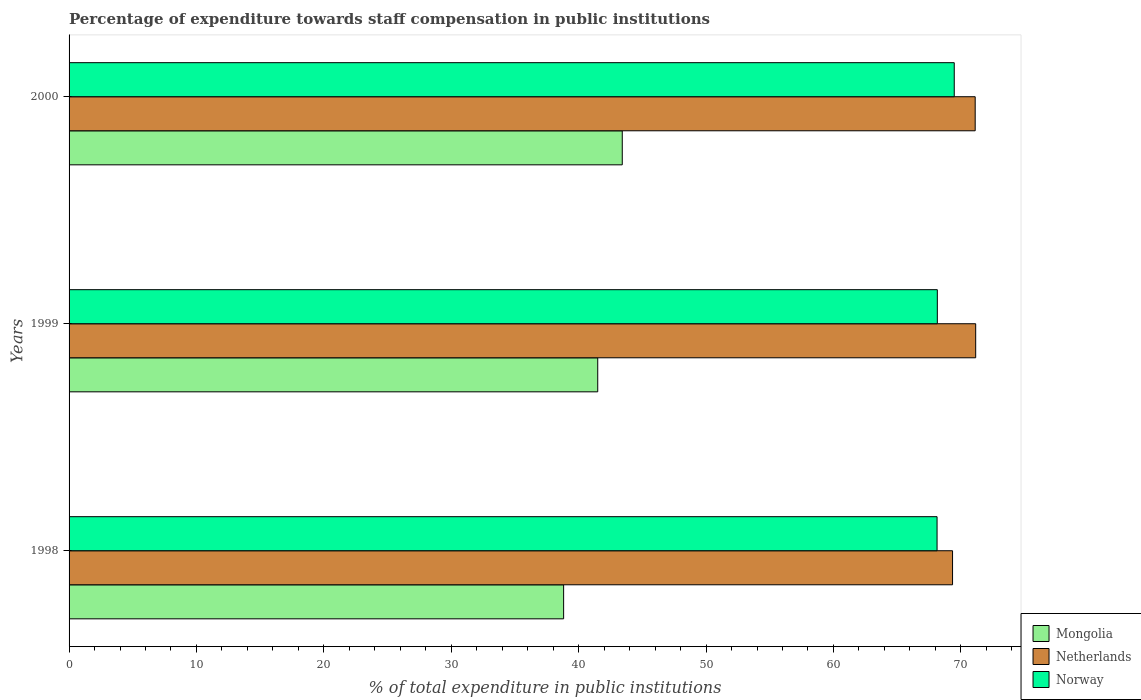How many different coloured bars are there?
Your answer should be compact. 3. How many groups of bars are there?
Ensure brevity in your answer.  3. How many bars are there on the 2nd tick from the top?
Your answer should be compact. 3. How many bars are there on the 2nd tick from the bottom?
Your answer should be compact. 3. In how many cases, is the number of bars for a given year not equal to the number of legend labels?
Make the answer very short. 0. What is the percentage of expenditure towards staff compensation in Mongolia in 1999?
Provide a succinct answer. 41.5. Across all years, what is the maximum percentage of expenditure towards staff compensation in Mongolia?
Your answer should be compact. 43.42. Across all years, what is the minimum percentage of expenditure towards staff compensation in Mongolia?
Your answer should be compact. 38.82. In which year was the percentage of expenditure towards staff compensation in Mongolia maximum?
Offer a very short reply. 2000. What is the total percentage of expenditure towards staff compensation in Netherlands in the graph?
Your response must be concise. 211.65. What is the difference between the percentage of expenditure towards staff compensation in Netherlands in 1999 and that in 2000?
Your response must be concise. 0.04. What is the difference between the percentage of expenditure towards staff compensation in Mongolia in 1998 and the percentage of expenditure towards staff compensation in Norway in 1999?
Give a very brief answer. -29.34. What is the average percentage of expenditure towards staff compensation in Norway per year?
Offer a very short reply. 68.59. In the year 1999, what is the difference between the percentage of expenditure towards staff compensation in Norway and percentage of expenditure towards staff compensation in Mongolia?
Make the answer very short. 26.66. What is the ratio of the percentage of expenditure towards staff compensation in Netherlands in 1998 to that in 1999?
Offer a terse response. 0.97. Is the percentage of expenditure towards staff compensation in Mongolia in 1999 less than that in 2000?
Provide a short and direct response. Yes. What is the difference between the highest and the second highest percentage of expenditure towards staff compensation in Norway?
Ensure brevity in your answer.  1.33. What is the difference between the highest and the lowest percentage of expenditure towards staff compensation in Norway?
Your response must be concise. 1.35. In how many years, is the percentage of expenditure towards staff compensation in Norway greater than the average percentage of expenditure towards staff compensation in Norway taken over all years?
Ensure brevity in your answer.  1. What does the 1st bar from the top in 1999 represents?
Your response must be concise. Norway. What does the 3rd bar from the bottom in 1998 represents?
Offer a terse response. Norway. How many bars are there?
Give a very brief answer. 9. Are all the bars in the graph horizontal?
Provide a short and direct response. Yes. Does the graph contain grids?
Ensure brevity in your answer.  No. How many legend labels are there?
Provide a succinct answer. 3. What is the title of the graph?
Make the answer very short. Percentage of expenditure towards staff compensation in public institutions. Does "Seychelles" appear as one of the legend labels in the graph?
Keep it short and to the point. No. What is the label or title of the X-axis?
Make the answer very short. % of total expenditure in public institutions. What is the % of total expenditure in public institutions of Mongolia in 1998?
Provide a short and direct response. 38.82. What is the % of total expenditure in public institutions in Netherlands in 1998?
Keep it short and to the point. 69.35. What is the % of total expenditure in public institutions of Norway in 1998?
Provide a short and direct response. 68.14. What is the % of total expenditure in public institutions of Mongolia in 1999?
Your response must be concise. 41.5. What is the % of total expenditure in public institutions in Netherlands in 1999?
Offer a terse response. 71.17. What is the % of total expenditure in public institutions in Norway in 1999?
Keep it short and to the point. 68.16. What is the % of total expenditure in public institutions of Mongolia in 2000?
Ensure brevity in your answer.  43.42. What is the % of total expenditure in public institutions in Netherlands in 2000?
Give a very brief answer. 71.13. What is the % of total expenditure in public institutions in Norway in 2000?
Ensure brevity in your answer.  69.48. Across all years, what is the maximum % of total expenditure in public institutions of Mongolia?
Offer a very short reply. 43.42. Across all years, what is the maximum % of total expenditure in public institutions of Netherlands?
Your response must be concise. 71.17. Across all years, what is the maximum % of total expenditure in public institutions of Norway?
Offer a terse response. 69.48. Across all years, what is the minimum % of total expenditure in public institutions in Mongolia?
Offer a terse response. 38.82. Across all years, what is the minimum % of total expenditure in public institutions in Netherlands?
Your answer should be compact. 69.35. Across all years, what is the minimum % of total expenditure in public institutions in Norway?
Your answer should be very brief. 68.14. What is the total % of total expenditure in public institutions of Mongolia in the graph?
Give a very brief answer. 123.74. What is the total % of total expenditure in public institutions of Netherlands in the graph?
Give a very brief answer. 211.65. What is the total % of total expenditure in public institutions in Norway in the graph?
Ensure brevity in your answer.  205.78. What is the difference between the % of total expenditure in public institutions in Mongolia in 1998 and that in 1999?
Keep it short and to the point. -2.68. What is the difference between the % of total expenditure in public institutions in Netherlands in 1998 and that in 1999?
Ensure brevity in your answer.  -1.82. What is the difference between the % of total expenditure in public institutions in Norway in 1998 and that in 1999?
Provide a short and direct response. -0.02. What is the difference between the % of total expenditure in public institutions of Mongolia in 1998 and that in 2000?
Your answer should be very brief. -4.6. What is the difference between the % of total expenditure in public institutions of Netherlands in 1998 and that in 2000?
Provide a short and direct response. -1.78. What is the difference between the % of total expenditure in public institutions in Norway in 1998 and that in 2000?
Keep it short and to the point. -1.35. What is the difference between the % of total expenditure in public institutions of Mongolia in 1999 and that in 2000?
Your answer should be compact. -1.93. What is the difference between the % of total expenditure in public institutions of Netherlands in 1999 and that in 2000?
Offer a very short reply. 0.04. What is the difference between the % of total expenditure in public institutions of Norway in 1999 and that in 2000?
Keep it short and to the point. -1.33. What is the difference between the % of total expenditure in public institutions in Mongolia in 1998 and the % of total expenditure in public institutions in Netherlands in 1999?
Offer a very short reply. -32.35. What is the difference between the % of total expenditure in public institutions in Mongolia in 1998 and the % of total expenditure in public institutions in Norway in 1999?
Make the answer very short. -29.34. What is the difference between the % of total expenditure in public institutions in Netherlands in 1998 and the % of total expenditure in public institutions in Norway in 1999?
Your answer should be compact. 1.19. What is the difference between the % of total expenditure in public institutions of Mongolia in 1998 and the % of total expenditure in public institutions of Netherlands in 2000?
Offer a terse response. -32.31. What is the difference between the % of total expenditure in public institutions in Mongolia in 1998 and the % of total expenditure in public institutions in Norway in 2000?
Offer a terse response. -30.66. What is the difference between the % of total expenditure in public institutions in Netherlands in 1998 and the % of total expenditure in public institutions in Norway in 2000?
Give a very brief answer. -0.13. What is the difference between the % of total expenditure in public institutions of Mongolia in 1999 and the % of total expenditure in public institutions of Netherlands in 2000?
Offer a very short reply. -29.63. What is the difference between the % of total expenditure in public institutions of Mongolia in 1999 and the % of total expenditure in public institutions of Norway in 2000?
Ensure brevity in your answer.  -27.98. What is the difference between the % of total expenditure in public institutions in Netherlands in 1999 and the % of total expenditure in public institutions in Norway in 2000?
Keep it short and to the point. 1.68. What is the average % of total expenditure in public institutions of Mongolia per year?
Your answer should be very brief. 41.25. What is the average % of total expenditure in public institutions in Netherlands per year?
Your answer should be very brief. 70.55. What is the average % of total expenditure in public institutions of Norway per year?
Provide a short and direct response. 68.59. In the year 1998, what is the difference between the % of total expenditure in public institutions of Mongolia and % of total expenditure in public institutions of Netherlands?
Your answer should be compact. -30.53. In the year 1998, what is the difference between the % of total expenditure in public institutions in Mongolia and % of total expenditure in public institutions in Norway?
Give a very brief answer. -29.31. In the year 1998, what is the difference between the % of total expenditure in public institutions in Netherlands and % of total expenditure in public institutions in Norway?
Your answer should be compact. 1.22. In the year 1999, what is the difference between the % of total expenditure in public institutions in Mongolia and % of total expenditure in public institutions in Netherlands?
Your answer should be very brief. -29.67. In the year 1999, what is the difference between the % of total expenditure in public institutions in Mongolia and % of total expenditure in public institutions in Norway?
Your response must be concise. -26.66. In the year 1999, what is the difference between the % of total expenditure in public institutions in Netherlands and % of total expenditure in public institutions in Norway?
Keep it short and to the point. 3.01. In the year 2000, what is the difference between the % of total expenditure in public institutions of Mongolia and % of total expenditure in public institutions of Netherlands?
Your response must be concise. -27.7. In the year 2000, what is the difference between the % of total expenditure in public institutions of Mongolia and % of total expenditure in public institutions of Norway?
Your answer should be very brief. -26.06. In the year 2000, what is the difference between the % of total expenditure in public institutions in Netherlands and % of total expenditure in public institutions in Norway?
Provide a succinct answer. 1.64. What is the ratio of the % of total expenditure in public institutions of Mongolia in 1998 to that in 1999?
Your response must be concise. 0.94. What is the ratio of the % of total expenditure in public institutions of Netherlands in 1998 to that in 1999?
Offer a very short reply. 0.97. What is the ratio of the % of total expenditure in public institutions of Norway in 1998 to that in 1999?
Your answer should be compact. 1. What is the ratio of the % of total expenditure in public institutions of Mongolia in 1998 to that in 2000?
Your response must be concise. 0.89. What is the ratio of the % of total expenditure in public institutions in Netherlands in 1998 to that in 2000?
Offer a very short reply. 0.97. What is the ratio of the % of total expenditure in public institutions of Norway in 1998 to that in 2000?
Ensure brevity in your answer.  0.98. What is the ratio of the % of total expenditure in public institutions in Mongolia in 1999 to that in 2000?
Make the answer very short. 0.96. What is the ratio of the % of total expenditure in public institutions of Netherlands in 1999 to that in 2000?
Your answer should be compact. 1. What is the ratio of the % of total expenditure in public institutions of Norway in 1999 to that in 2000?
Offer a very short reply. 0.98. What is the difference between the highest and the second highest % of total expenditure in public institutions of Mongolia?
Make the answer very short. 1.93. What is the difference between the highest and the second highest % of total expenditure in public institutions in Netherlands?
Keep it short and to the point. 0.04. What is the difference between the highest and the second highest % of total expenditure in public institutions of Norway?
Keep it short and to the point. 1.33. What is the difference between the highest and the lowest % of total expenditure in public institutions in Mongolia?
Give a very brief answer. 4.6. What is the difference between the highest and the lowest % of total expenditure in public institutions in Netherlands?
Offer a terse response. 1.82. What is the difference between the highest and the lowest % of total expenditure in public institutions in Norway?
Provide a succinct answer. 1.35. 